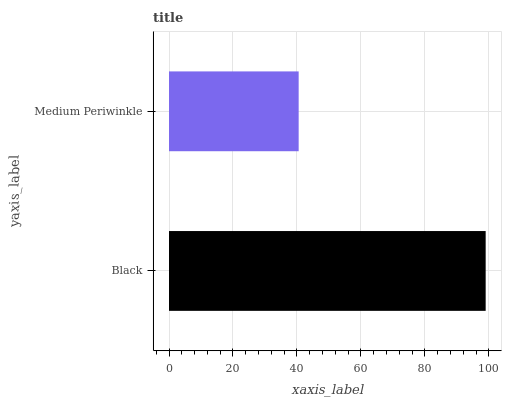Is Medium Periwinkle the minimum?
Answer yes or no. Yes. Is Black the maximum?
Answer yes or no. Yes. Is Medium Periwinkle the maximum?
Answer yes or no. No. Is Black greater than Medium Periwinkle?
Answer yes or no. Yes. Is Medium Periwinkle less than Black?
Answer yes or no. Yes. Is Medium Periwinkle greater than Black?
Answer yes or no. No. Is Black less than Medium Periwinkle?
Answer yes or no. No. Is Black the high median?
Answer yes or no. Yes. Is Medium Periwinkle the low median?
Answer yes or no. Yes. Is Medium Periwinkle the high median?
Answer yes or no. No. Is Black the low median?
Answer yes or no. No. 